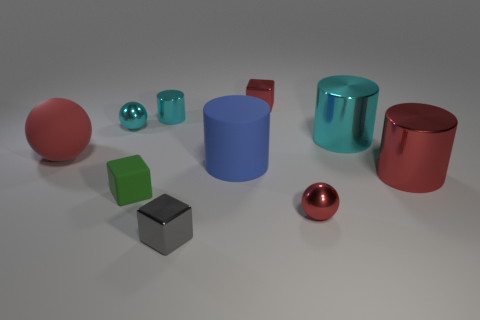Subtract all small metallic spheres. How many spheres are left? 1 Subtract all cyan cylinders. How many cylinders are left? 2 Subtract all spheres. How many objects are left? 7 Subtract 2 cylinders. How many cylinders are left? 2 Subtract all gray cubes. Subtract all small gray metal objects. How many objects are left? 8 Add 3 green cubes. How many green cubes are left? 4 Add 5 small shiny objects. How many small shiny objects exist? 10 Subtract 0 brown balls. How many objects are left? 10 Subtract all green cylinders. Subtract all purple cubes. How many cylinders are left? 4 Subtract all blue balls. How many cyan cubes are left? 0 